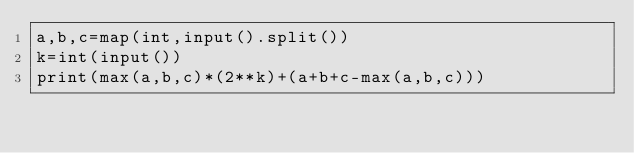<code> <loc_0><loc_0><loc_500><loc_500><_Python_>a,b,c=map(int,input().split())
k=int(input())
print(max(a,b,c)*(2**k)+(a+b+c-max(a,b,c)))</code> 